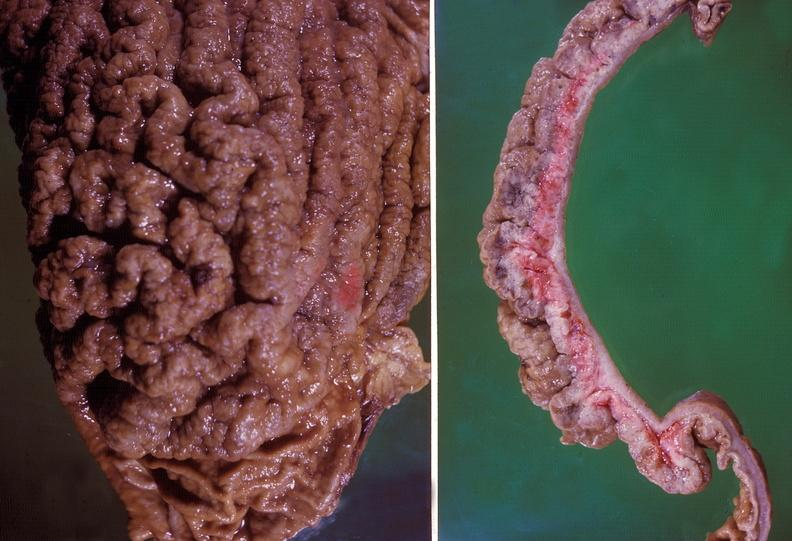what is present?
Answer the question using a single word or phrase. Gastrointestinal 